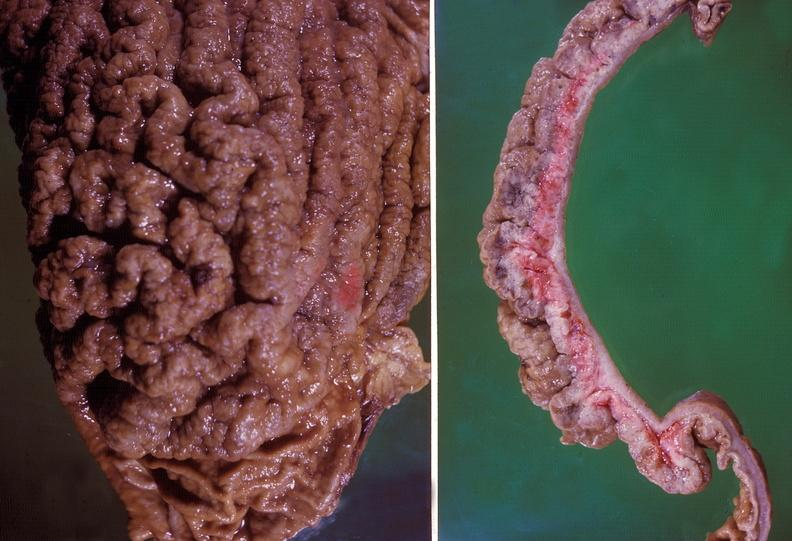what is present?
Answer the question using a single word or phrase. Gastrointestinal 